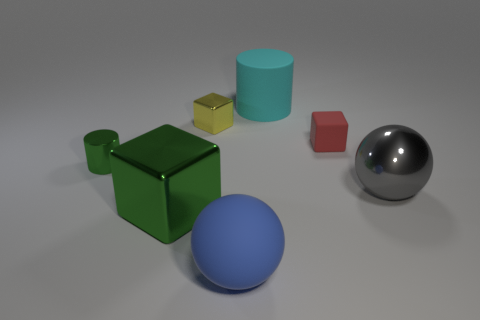Are there an equal number of blue objects on the right side of the red rubber object and small gray shiny cylinders?
Keep it short and to the point. Yes. There is a cylinder that is in front of the cyan rubber cylinder; is its color the same as the big thing to the left of the large blue rubber object?
Your answer should be very brief. Yes. How many objects are in front of the large cyan matte object and behind the red cube?
Your response must be concise. 1. What number of other objects are there of the same shape as the large green metal object?
Your answer should be compact. 2. Is the number of balls to the right of the big cyan matte object greater than the number of large green balls?
Provide a short and direct response. Yes. There is a tiny cube to the right of the large cylinder; what color is it?
Provide a short and direct response. Red. There is a cylinder that is the same color as the big shiny cube; what size is it?
Provide a short and direct response. Small. What number of shiny objects are either big blue balls or large yellow spheres?
Provide a short and direct response. 0. There is a large metal cube right of the tiny metallic cylinder to the left of the tiny matte cube; are there any tiny green shiny cylinders behind it?
Provide a short and direct response. Yes. What number of big gray metallic things are in front of the big green thing?
Give a very brief answer. 0. 